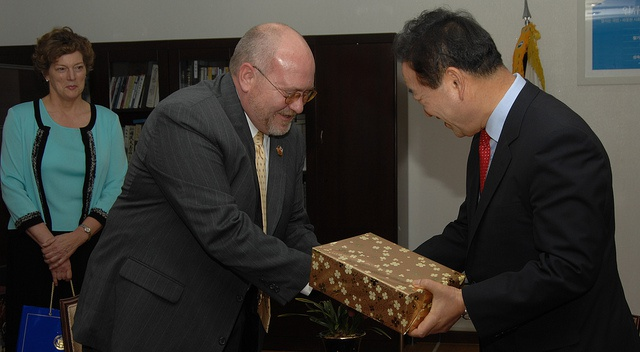Describe the objects in this image and their specific colors. I can see people in gray, black, and tan tones, people in gray, black, and maroon tones, people in gray, black, and teal tones, handbag in gray, navy, black, and darkgreen tones, and tie in gray, black, tan, and maroon tones in this image. 